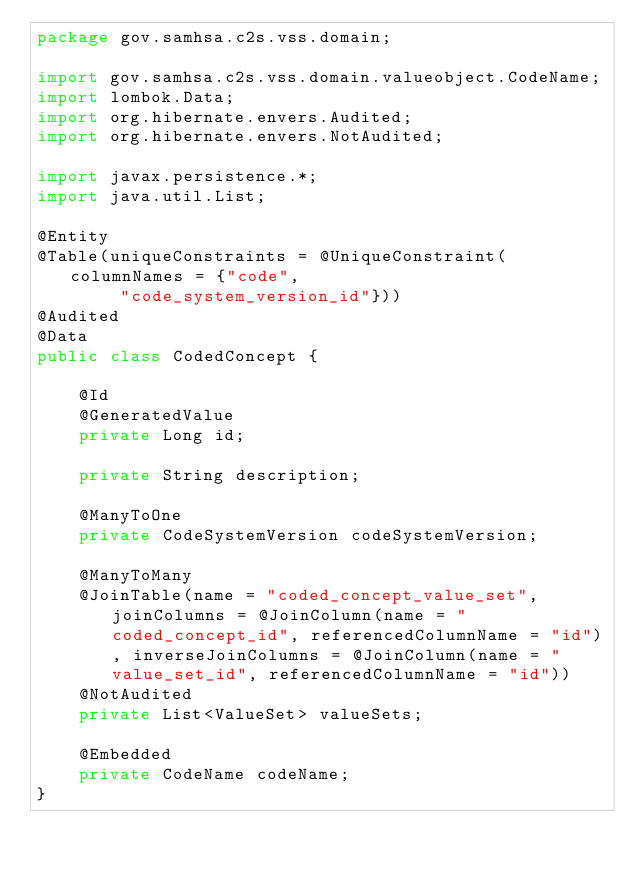Convert code to text. <code><loc_0><loc_0><loc_500><loc_500><_Java_>package gov.samhsa.c2s.vss.domain;

import gov.samhsa.c2s.vss.domain.valueobject.CodeName;
import lombok.Data;
import org.hibernate.envers.Audited;
import org.hibernate.envers.NotAudited;

import javax.persistence.*;
import java.util.List;

@Entity
@Table(uniqueConstraints = @UniqueConstraint(columnNames = {"code",
        "code_system_version_id"}))
@Audited
@Data
public class CodedConcept {

    @Id
    @GeneratedValue
    private Long id;

    private String description;

    @ManyToOne
    private CodeSystemVersion codeSystemVersion;

    @ManyToMany
    @JoinTable(name = "coded_concept_value_set", joinColumns = @JoinColumn(name = "coded_concept_id", referencedColumnName = "id"), inverseJoinColumns = @JoinColumn(name = "value_set_id", referencedColumnName = "id"))
    @NotAudited
    private List<ValueSet> valueSets;

    @Embedded
    private CodeName codeName;
}</code> 